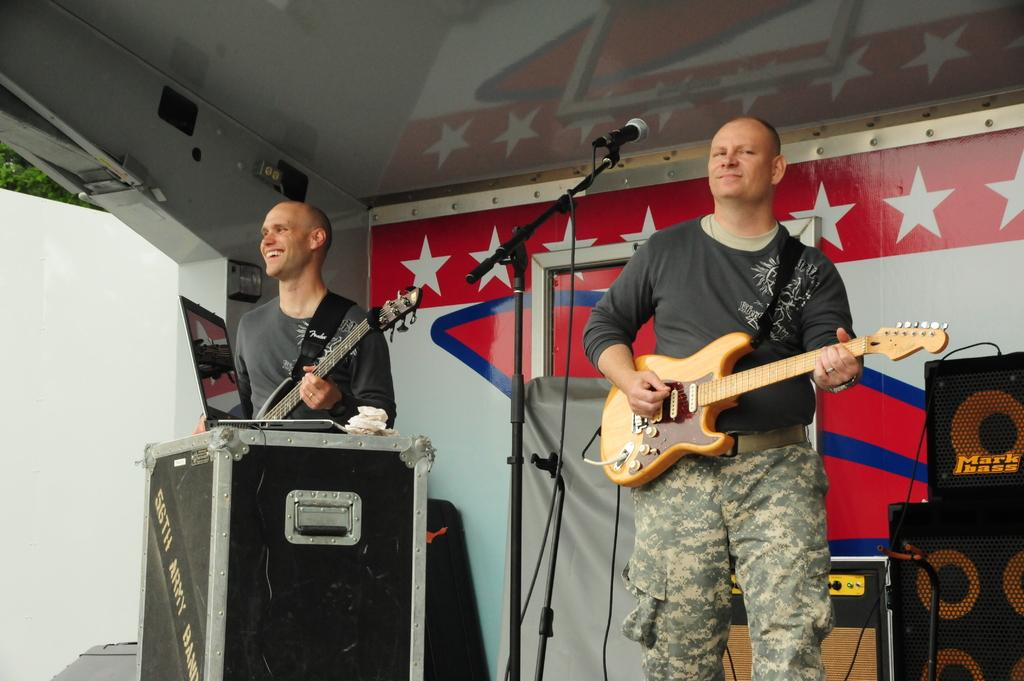How many people are in the image? There are two persons standing in the image. What are the persons holding? The persons are holding guitars. What object is in front of one of the persons? There is a microphone in front of one of the persons. What can be seen in the background of the image? There are speakers, a tent, and trees in the background of the image. What type of clam is being used as a musical instrument in the image? There is no clam present in the image; the persons are holding guitars as musical instruments. What is the source of pleasure for the persons in the image? The provided facts do not mention the source of pleasure for the persons in the image. 